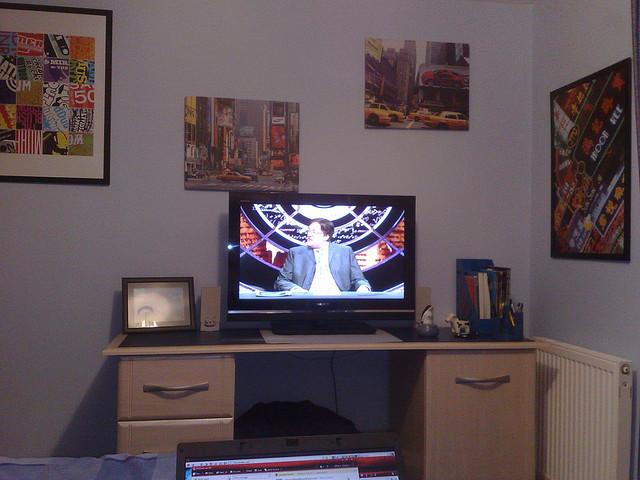What kind of artwork is framed on the left side of the screen on the wall?

Choices:
A) abstract
B) contemporary
C) impressionism
D) american pop american pop 